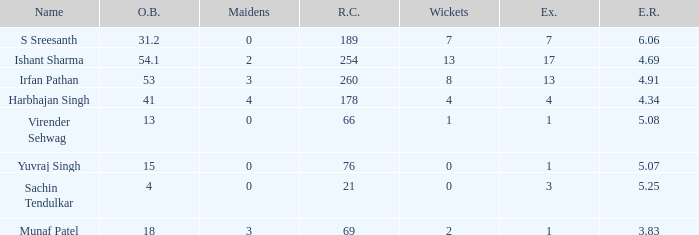Name the name for when overs bowled is 31.2 S Sreesanth. 